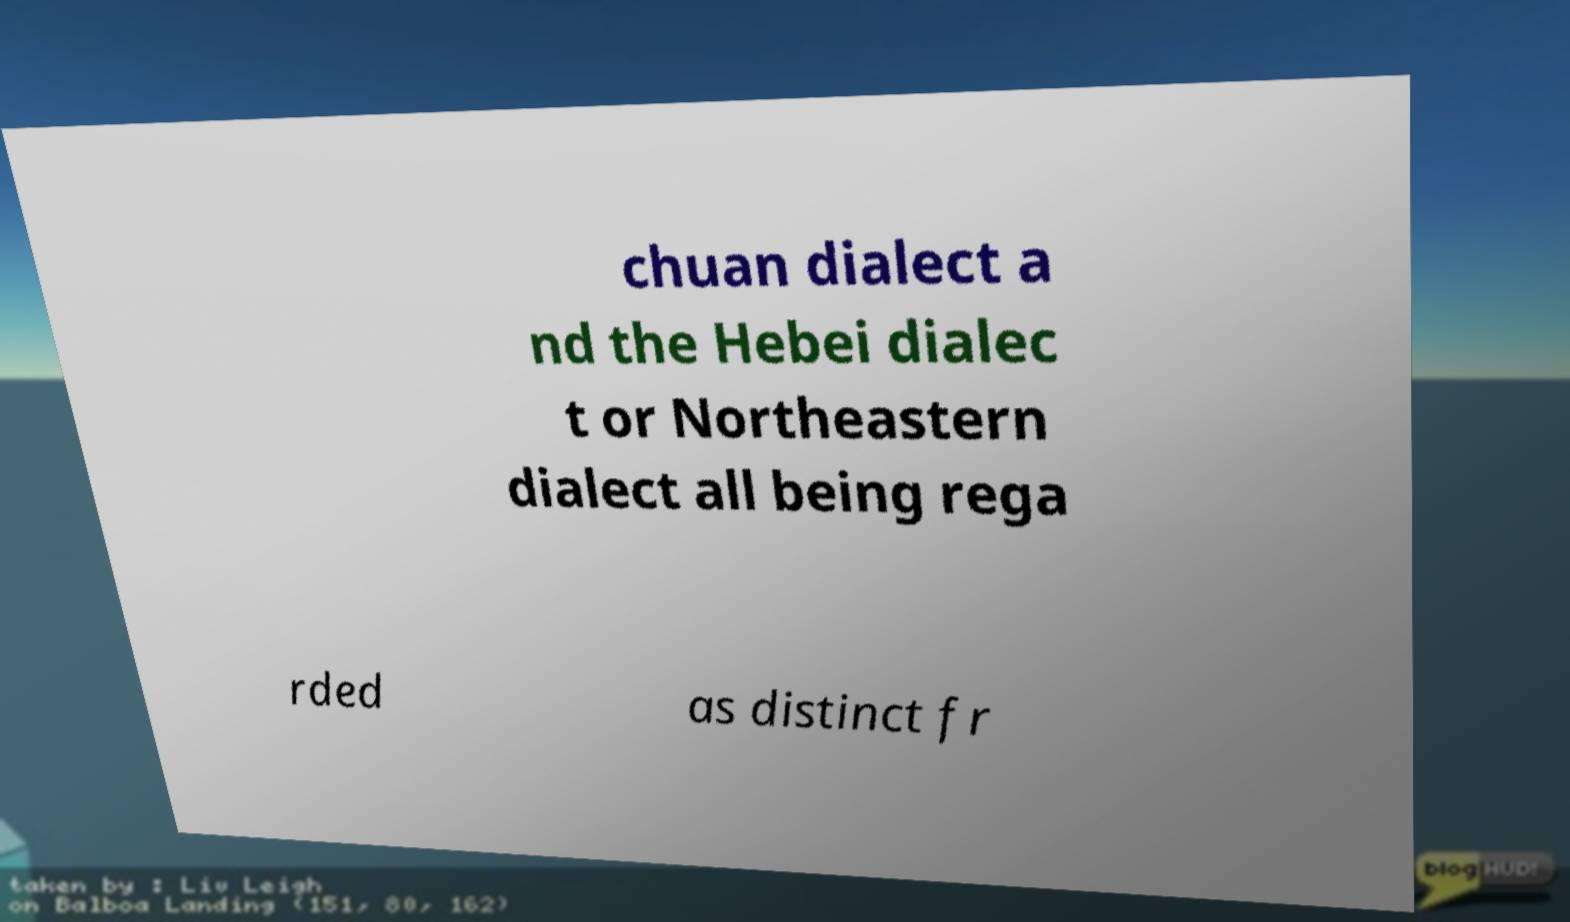For documentation purposes, I need the text within this image transcribed. Could you provide that? chuan dialect a nd the Hebei dialec t or Northeastern dialect all being rega rded as distinct fr 